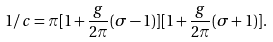<formula> <loc_0><loc_0><loc_500><loc_500>1 / c = \pi [ 1 + \frac { g } { 2 \pi } ( \sigma - 1 ) ] [ 1 + \frac { g } { 2 \pi } ( \sigma + 1 ) ] .</formula> 